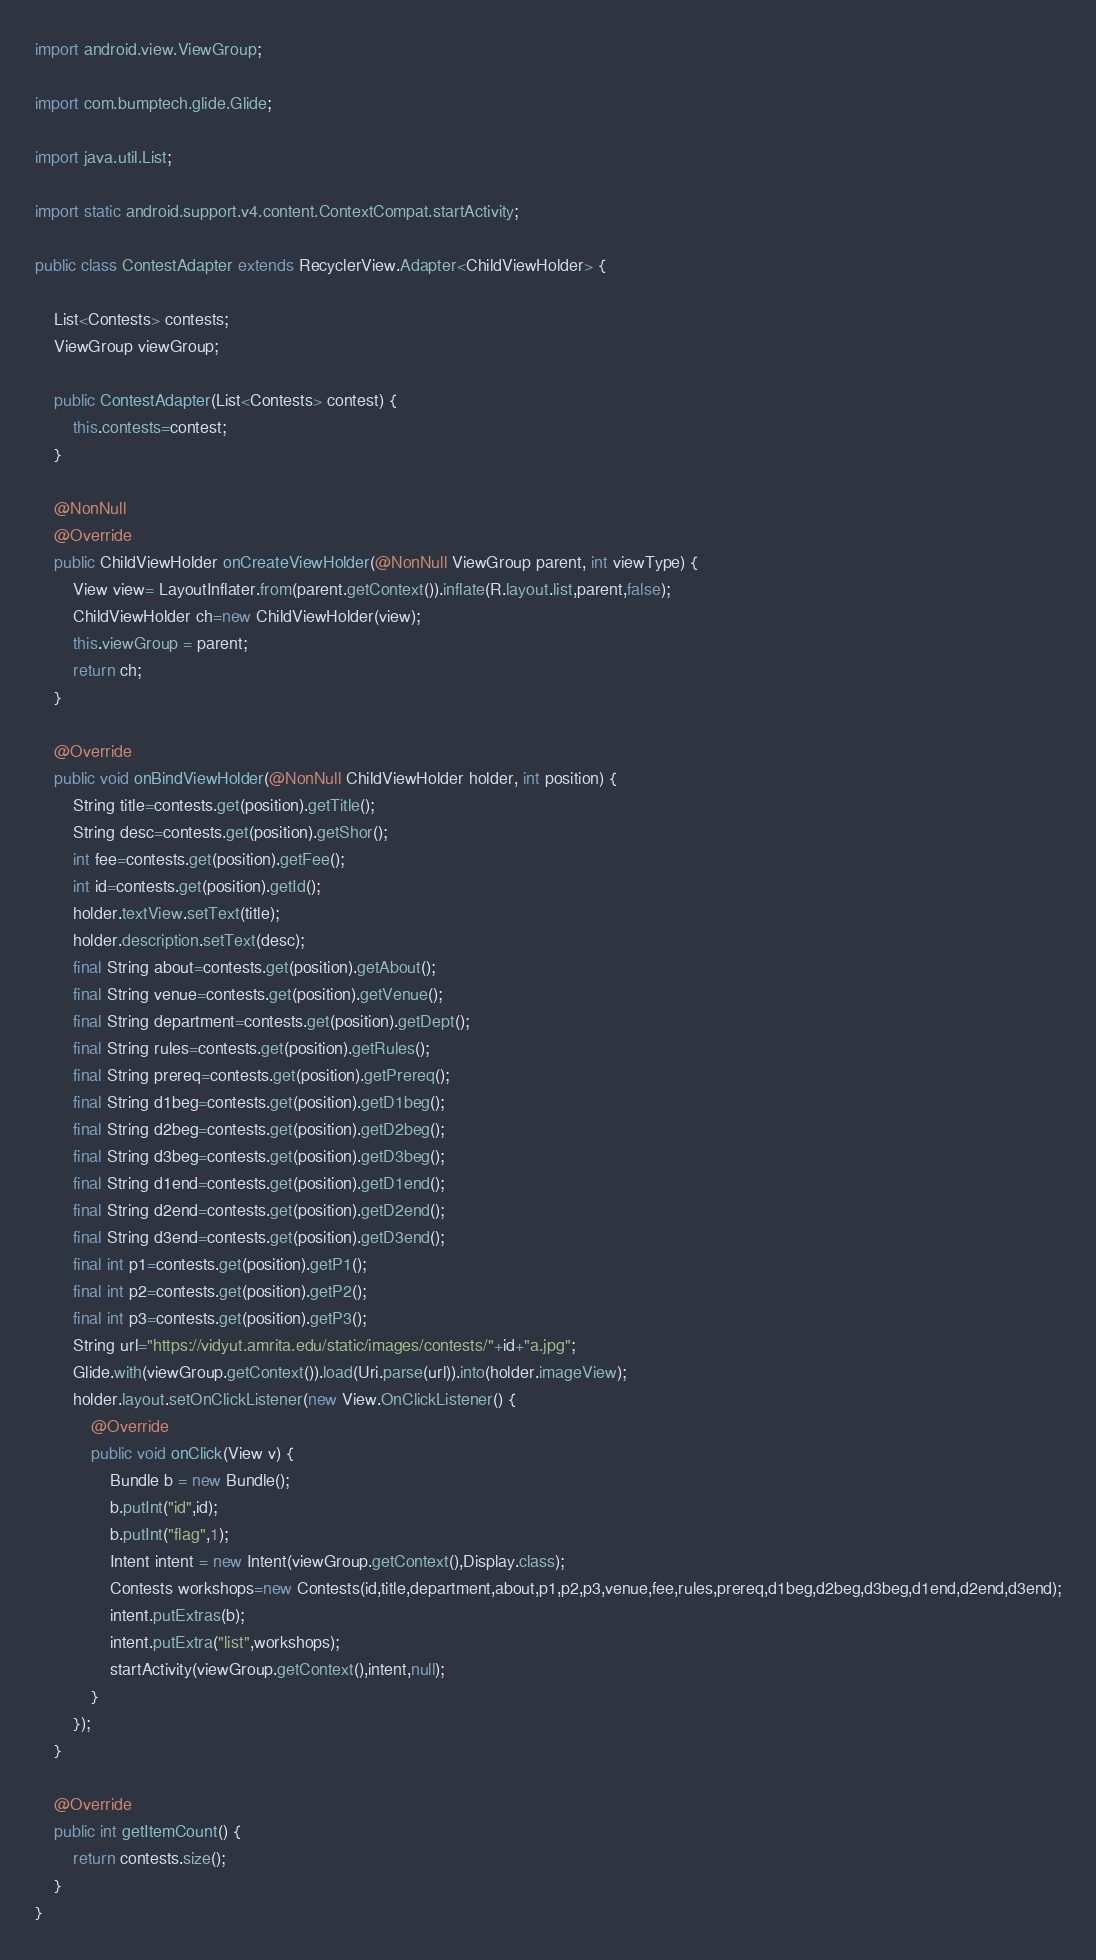Convert code to text. <code><loc_0><loc_0><loc_500><loc_500><_Java_>import android.view.ViewGroup;

import com.bumptech.glide.Glide;

import java.util.List;

import static android.support.v4.content.ContextCompat.startActivity;

public class ContestAdapter extends RecyclerView.Adapter<ChildViewHolder> {

    List<Contests> contests;
    ViewGroup viewGroup;

    public ContestAdapter(List<Contests> contest) {
        this.contests=contest;
    }

    @NonNull
    @Override
    public ChildViewHolder onCreateViewHolder(@NonNull ViewGroup parent, int viewType) {
        View view= LayoutInflater.from(parent.getContext()).inflate(R.layout.list,parent,false);
        ChildViewHolder ch=new ChildViewHolder(view);
        this.viewGroup = parent;
        return ch;
    }

    @Override
    public void onBindViewHolder(@NonNull ChildViewHolder holder, int position) {
        String title=contests.get(position).getTitle();
        String desc=contests.get(position).getShor();
        int fee=contests.get(position).getFee();
        int id=contests.get(position).getId();
        holder.textView.setText(title);
        holder.description.setText(desc);
        final String about=contests.get(position).getAbout();
        final String venue=contests.get(position).getVenue();
        final String department=contests.get(position).getDept();
        final String rules=contests.get(position).getRules();
        final String prereq=contests.get(position).getPrereq();
        final String d1beg=contests.get(position).getD1beg();
        final String d2beg=contests.get(position).getD2beg();
        final String d3beg=contests.get(position).getD3beg();
        final String d1end=contests.get(position).getD1end();
        final String d2end=contests.get(position).getD2end();
        final String d3end=contests.get(position).getD3end();
        final int p1=contests.get(position).getP1();
        final int p2=contests.get(position).getP2();
        final int p3=contests.get(position).getP3();
        String url="https://vidyut.amrita.edu/static/images/contests/"+id+"a.jpg";
        Glide.with(viewGroup.getContext()).load(Uri.parse(url)).into(holder.imageView);
        holder.layout.setOnClickListener(new View.OnClickListener() {
            @Override
            public void onClick(View v) {
                Bundle b = new Bundle();
                b.putInt("id",id);
                b.putInt("flag",1);
                Intent intent = new Intent(viewGroup.getContext(),Display.class);
                Contests workshops=new Contests(id,title,department,about,p1,p2,p3,venue,fee,rules,prereq,d1beg,d2beg,d3beg,d1end,d2end,d3end);
                intent.putExtras(b);
                intent.putExtra("list",workshops);
                startActivity(viewGroup.getContext(),intent,null);
            }
        });
    }

    @Override
    public int getItemCount() {
        return contests.size();
    }
}
</code> 